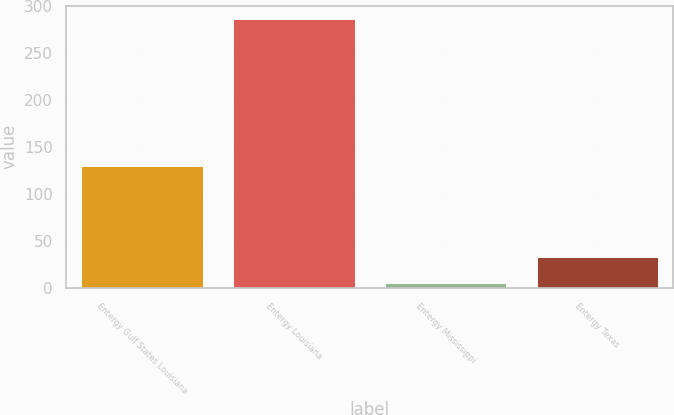Convert chart to OTSL. <chart><loc_0><loc_0><loc_500><loc_500><bar_chart><fcel>Entergy Gulf States Louisiana<fcel>Entergy Louisiana<fcel>Entergy Mississippi<fcel>Entergy Texas<nl><fcel>129.6<fcel>286.7<fcel>5.3<fcel>33.44<nl></chart> 